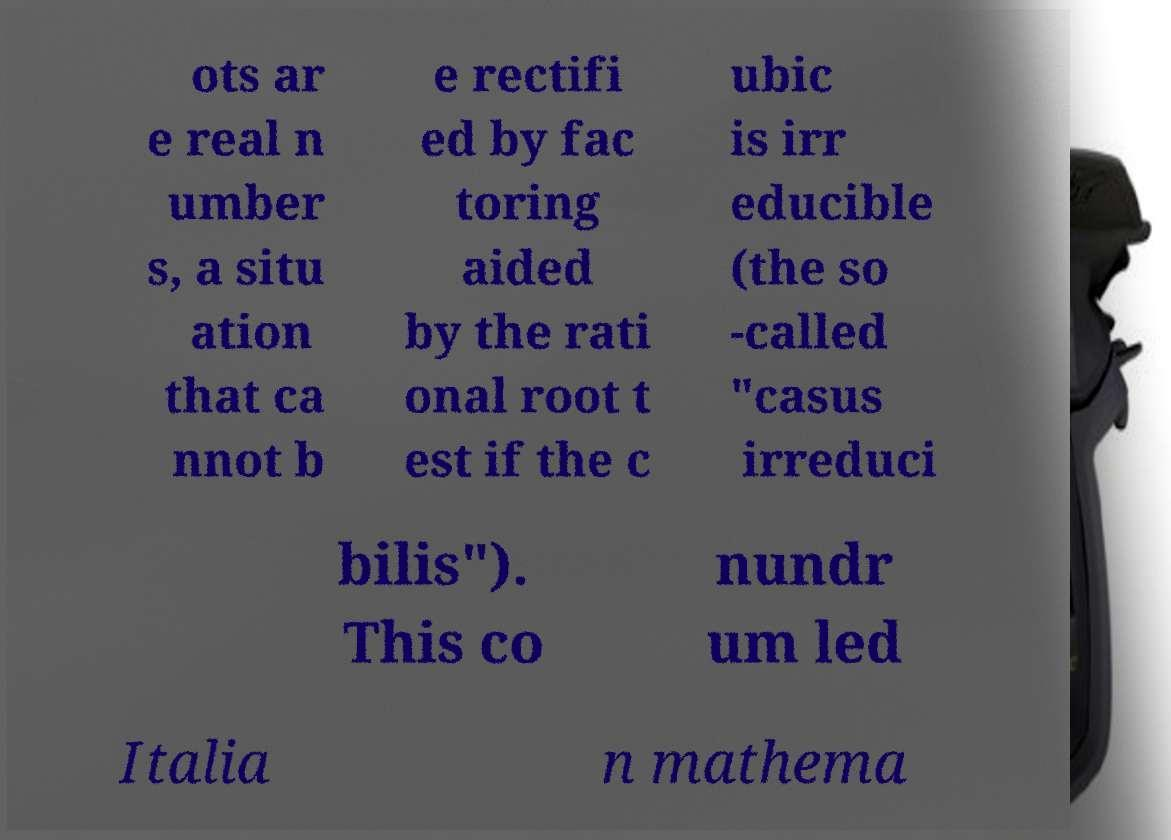Could you extract and type out the text from this image? ots ar e real n umber s, a situ ation that ca nnot b e rectifi ed by fac toring aided by the rati onal root t est if the c ubic is irr educible (the so -called "casus irreduci bilis"). This co nundr um led Italia n mathema 